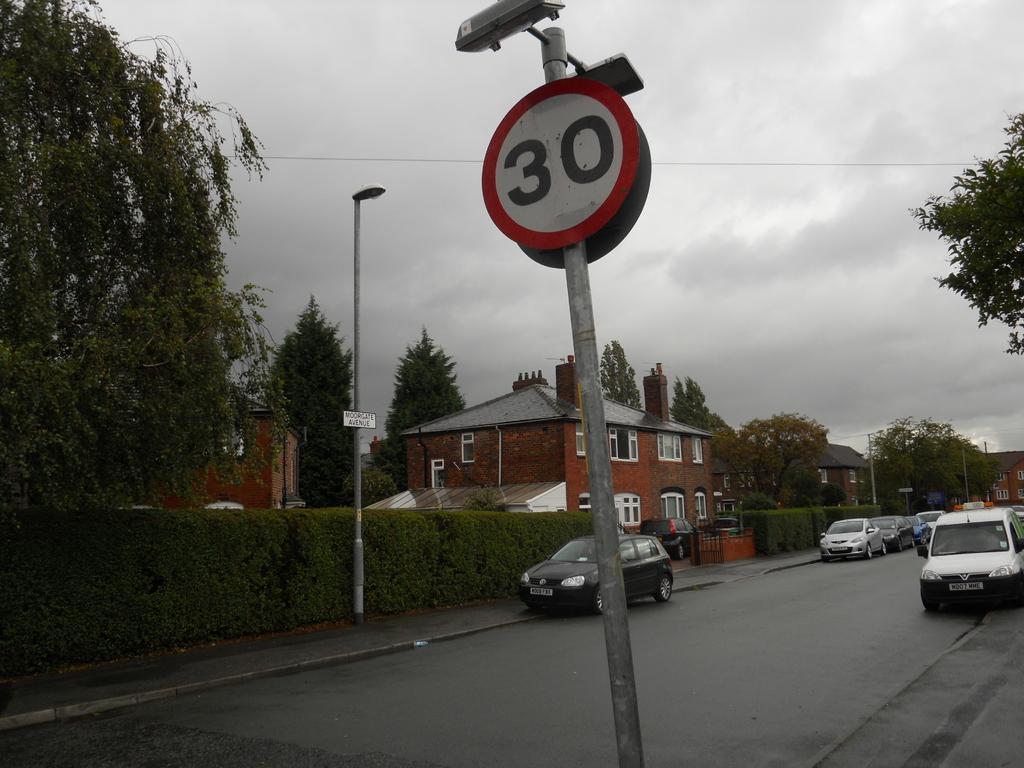Can you describe this image briefly? In the center of the image there is sign board and camera. On the right side of the image we can see vehicles on the road and tree. On The left side of the image we can see street light, tree and plants. In the background we can see buildings, trees, sky and clouds. 